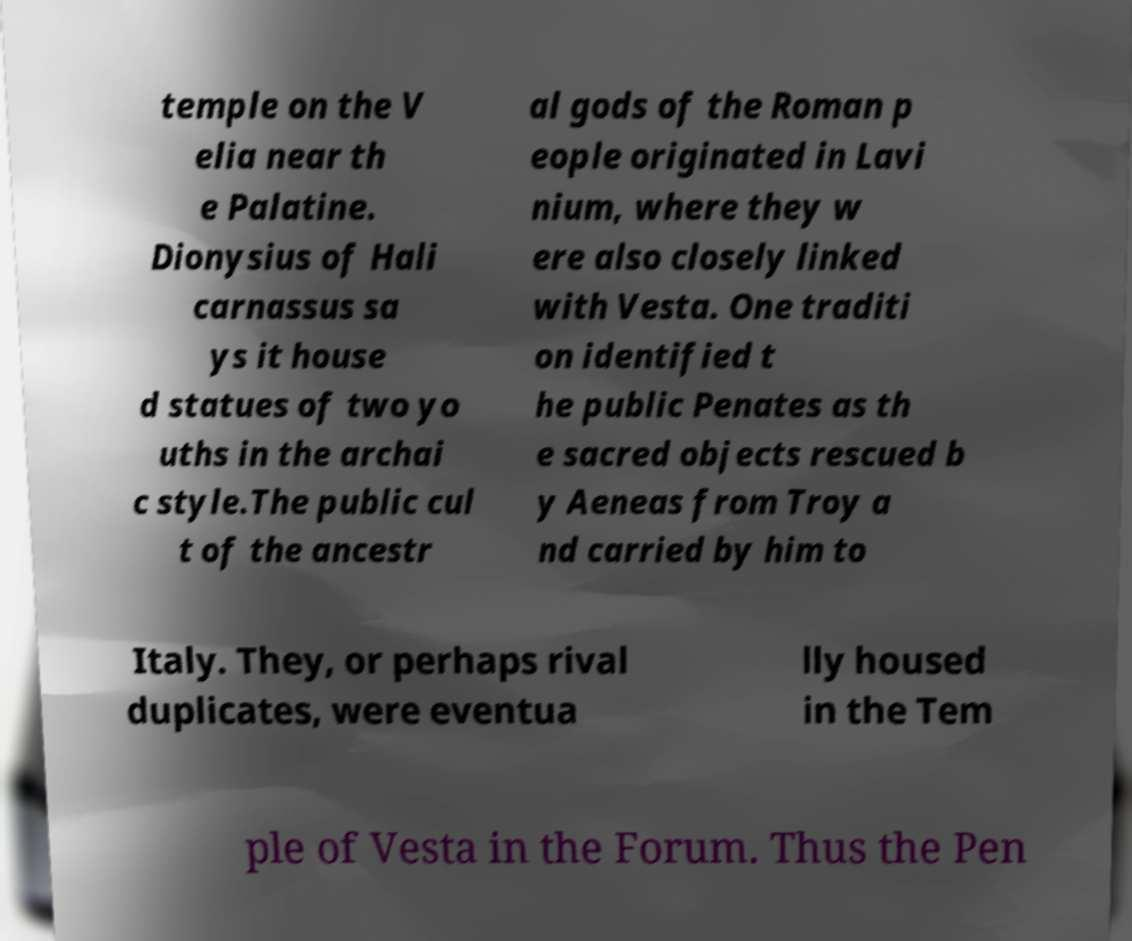Please identify and transcribe the text found in this image. temple on the V elia near th e Palatine. Dionysius of Hali carnassus sa ys it house d statues of two yo uths in the archai c style.The public cul t of the ancestr al gods of the Roman p eople originated in Lavi nium, where they w ere also closely linked with Vesta. One traditi on identified t he public Penates as th e sacred objects rescued b y Aeneas from Troy a nd carried by him to Italy. They, or perhaps rival duplicates, were eventua lly housed in the Tem ple of Vesta in the Forum. Thus the Pen 